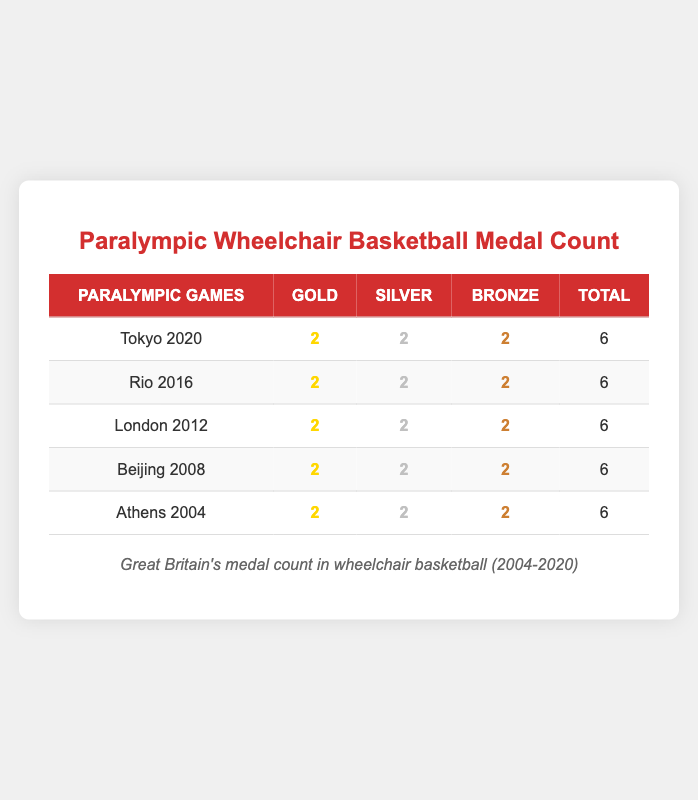What is the total number of medals won by Great Britain in the Tokyo 2020 Paralympic Games? The total number of medals won is provided in the "Total" column for Tokyo 2020, which shows 6 medals.
Answer: 6 How many Gold medals did Great Britain win in Rio 2016? The "Gold" column for Rio 2016 indicates that Great Britain won 2 Gold medals.
Answer: 2 Did Great Britain win more Silver medals in Beijing 2008 compared to London 2012? Both the Beijing 2008 and London 2012 events show 2 Silver medals, so the comparison results in them being equal.
Answer: No What is the total number of Gold medals won by Great Britain across all the Paralympic Games listed? To calculate the total Gold medals, sum the Gold column: 2 (Tokyo) + 2 (Rio) + 2 (London) + 2 (Beijing) + 2 (Athens) = 10.
Answer: 10 Which Paralympic Games did not result in a different number of Gold, Silver, and Bronze medals for Great Britain? All listed years (Tokyo 2020, Rio 2016, London 2012, Beijing 2008, and Athens 2004) show equal counts of 2 for Gold, Silver, and Bronze, meaning none have different values.
Answer: All years What is the average number of Bronze medals won by Great Britain over the listed Paralympic Games? To find the average, we sum the Bronze medals: 2 + 2 + 2 + 2 + 2 = 10 and then divide by the number of events (5): 10/5 = 2.
Answer: 2 Did Great Britain achieve a consistent medal count of 6 across all listed Paralympic Games? The total for each Paralympic Games (Tokyo 2020, Rio 2016, London 2012, Beijing 2008, Athens 2004) is consistently 6, verifying the statement.
Answer: Yes What is the difference in the total number of medals won between the most recent and the earliest Paralympic Games listed? The most recent event, Tokyo 2020, has 6 medals while the earliest, Athens 2004, also has 6. The difference is 6 - 6 = 0.
Answer: 0 